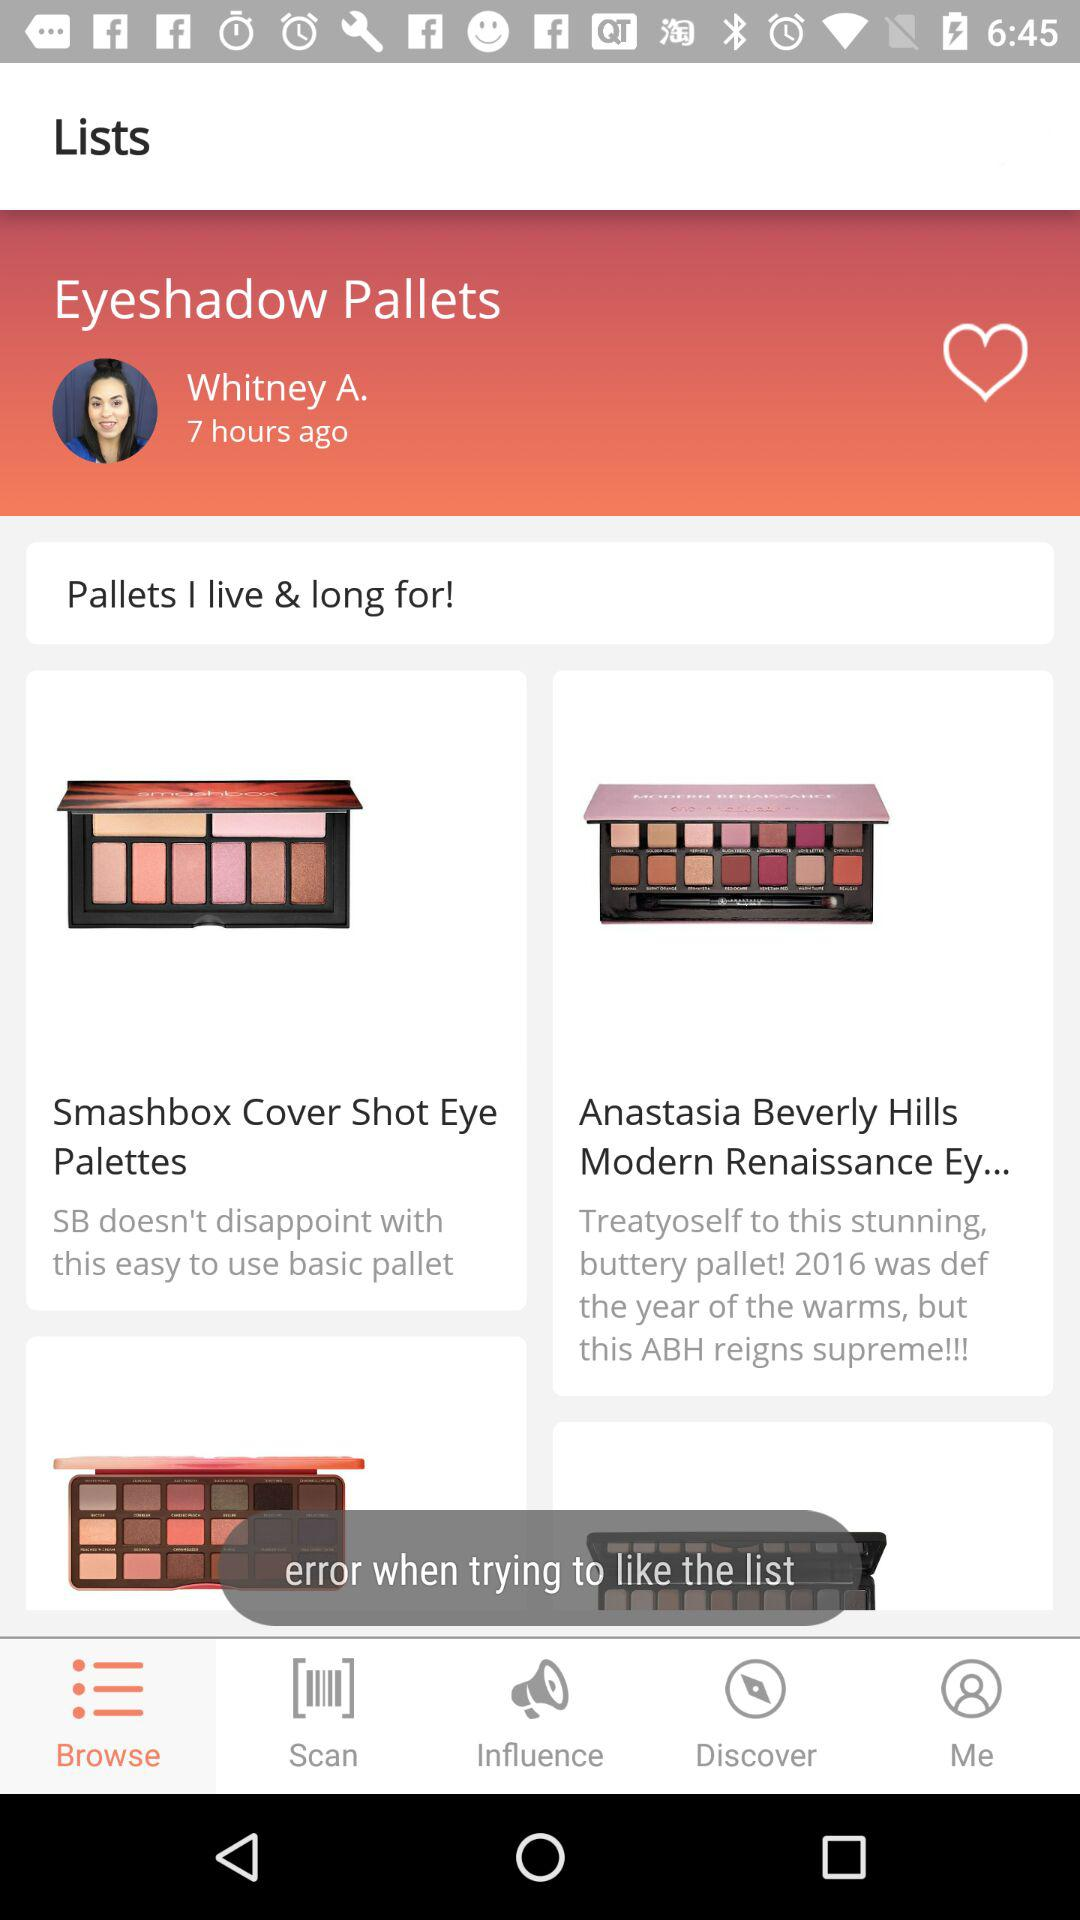Who posted the list "Eyeshadow Pallets"? The list "Eyeshadow Pallets" was posted by Whitney A. 